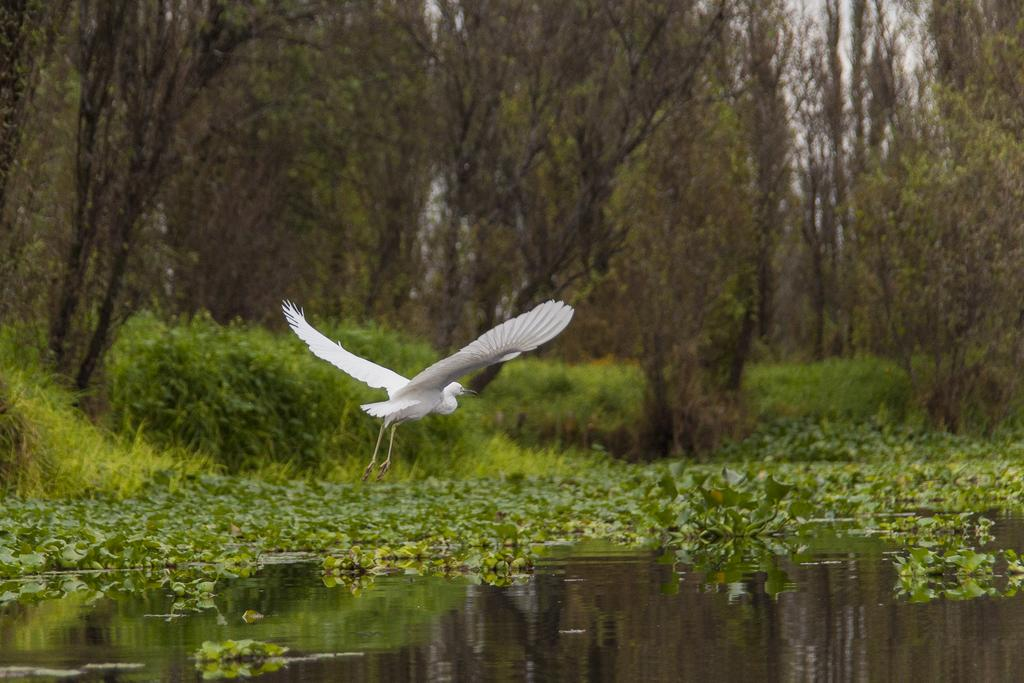What is the main subject of the image? There is a bird flying in the image. What can be seen in the background of the image? There are trees in the background of the image. What is unusual about the water in the image? Leaves are present on the surface of the water in the image. How many times does the bird shake its tail feathers in the image? There is no indication in the image that the bird is shaking its tail feathers, so it cannot be determined from the picture. 